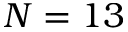Convert formula to latex. <formula><loc_0><loc_0><loc_500><loc_500>N = 1 3</formula> 